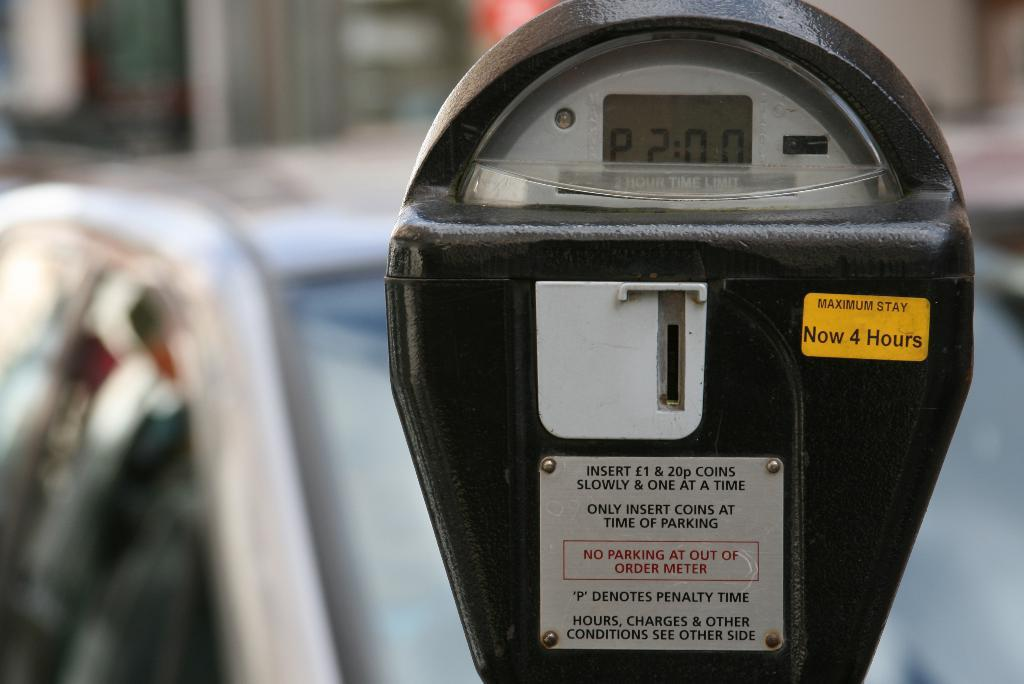<image>
Render a clear and concise summary of the photo. A parking meter says 2 minutes on it and has a sticker on it saying the maximum stay is now 4 hours 